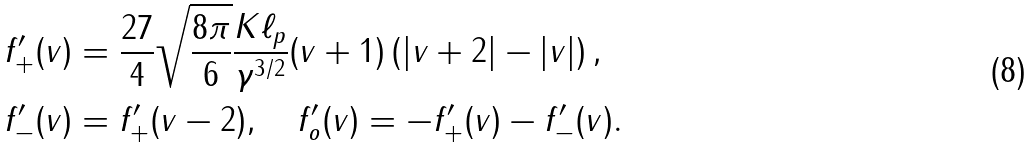<formula> <loc_0><loc_0><loc_500><loc_500>f ^ { \prime } _ { + } ( v ) & = \frac { 2 7 } { 4 } \sqrt { \frac { 8 \pi } { 6 } } \frac { K \ell _ { p } } { \gamma ^ { 3 / 2 } } ( v + 1 ) \left ( | v + 2 | - | v | \right ) , \\ f ^ { \prime } _ { - } ( v ) & = f ^ { \prime } _ { + } ( v - 2 ) , \quad f ^ { \prime } _ { o } ( v ) = - f ^ { \prime } _ { + } ( v ) - f ^ { \prime } _ { - } ( v ) .</formula> 